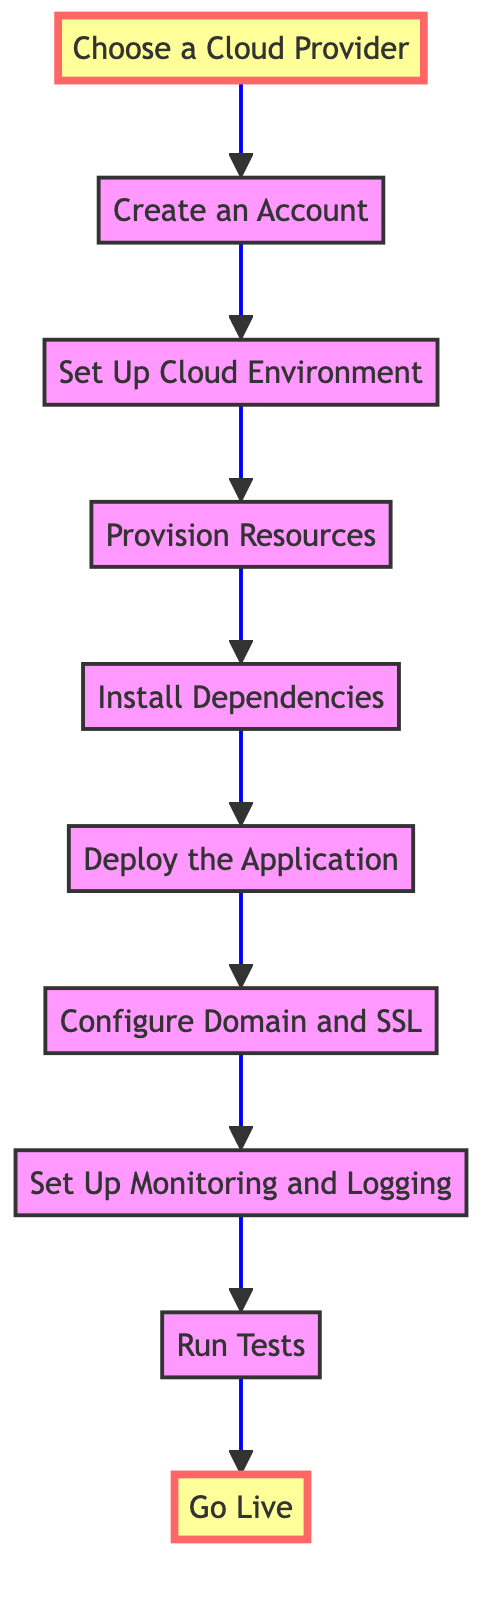What is the first step in the deployment process? The first step is indicated by node A, which states "Choose a Cloud Provider." This is the starting point of the flowchart where users begin their process of deploying a web application.
Answer: Choose a Cloud Provider How many total steps are in the flowchart? By counting the nodes from A to J (inclusive), we see there are 10 steps listed in the flowchart, representing the full process of deployment from start to finish.
Answer: 10 What follows the "Install Dependencies" step? Looking at the arrows connecting the nodes, the step "Deploy the Application" follows "Install Dependencies." This shows the sequential nature of the deployment process in the flowchart.
Answer: Deploy the Application Which step involves setting up monitoring tools? The flowchart indicates that "Set Up Monitoring and Logging" is the step that involves implementing monitoring tools. This is reflected by the placement of this node in the sequence.
Answer: Set Up Monitoring and Logging What is the last step in the deployment process? The last step of the flowchart is represented by node J, which is labeled "Go Live." This indicates that this is the final action taken after all preceding steps are completed.
Answer: Go Live What is necessary before deploying the application? Before deploying, one must complete the "Install Dependencies" step, as indicated by the flow from the previous step. This preparation is crucial for ensuring that the application runs correctly after deployment.
Answer: Install Dependencies Which step comes immediately after "Configure Domain and SSL"? The next step after "Configure Domain and SSL" is "Set Up Monitoring and Logging," as indicated by the arrow leading from the domain configuration step to the monitoring setup step.
Answer: Set Up Monitoring and Logging How many steps are there between "Choose a Cloud Provider" and "Go Live"? By counting the steps in the flow from "Choose a Cloud Provider" (step A) to "Go Live" (step J), we find there are 9 steps in total included in this path.
Answer: 9 What is required to make the web application publicly accessible? The flowchart shows that the final step, "Go Live," is where the web application is made publicly accessible, indicating that this step fulfills that requirement.
Answer: Go Live 